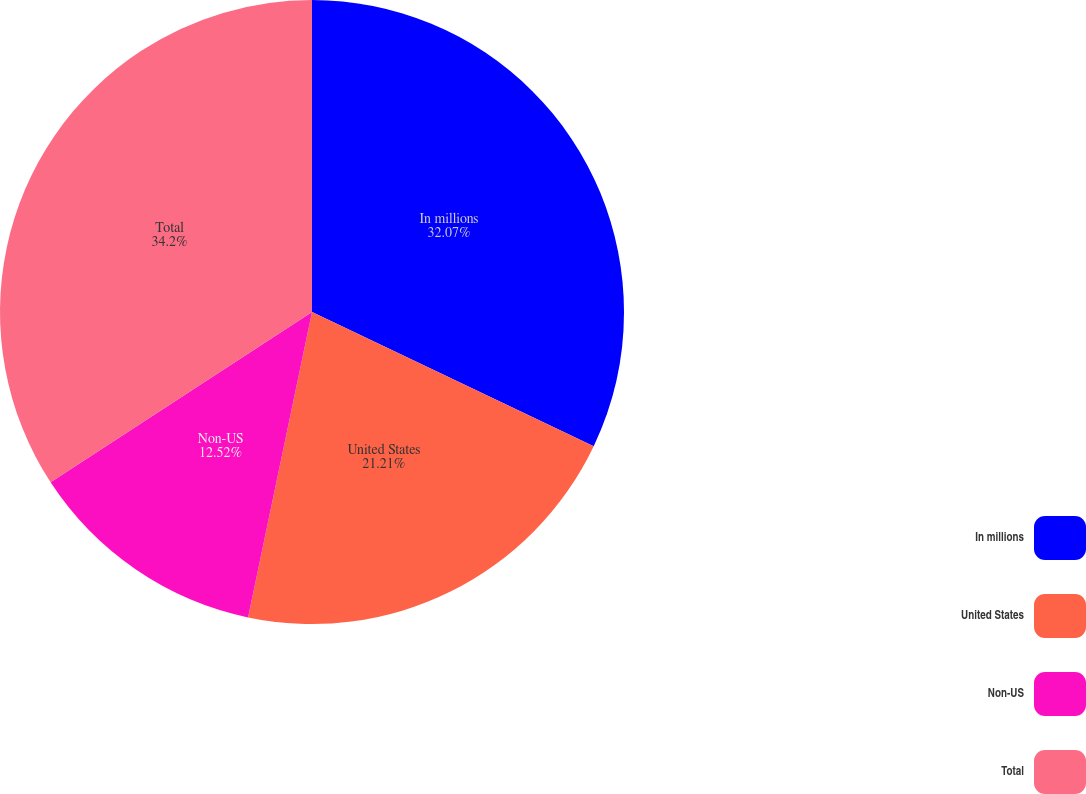<chart> <loc_0><loc_0><loc_500><loc_500><pie_chart><fcel>In millions<fcel>United States<fcel>Non-US<fcel>Total<nl><fcel>32.07%<fcel>21.21%<fcel>12.52%<fcel>34.19%<nl></chart> 